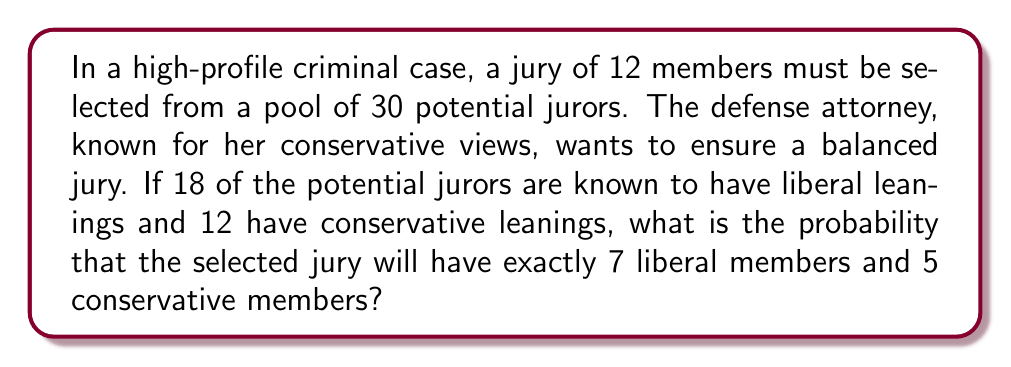Can you solve this math problem? Let's approach this step-by-step using combinatorics:

1) We need to select 7 liberal jurors out of 18 and 5 conservative jurors out of 12.

2) The number of ways to select 7 liberal jurors out of 18 is given by the combination formula:
   $$\binom{18}{7} = \frac{18!}{7!(18-7)!} = \frac{18!}{7!11!}$$

3) Similarly, the number of ways to select 5 conservative jurors out of 12 is:
   $$\binom{12}{5} = \frac{12!}{5!(12-5)!} = \frac{12!}{5!7!}$$

4) The total number of ways to select these specific combinations is the product of these two:
   $$\binom{18}{7} \cdot \binom{12}{5}$$

5) The total number of ways to select any 12 jurors out of 30 is:
   $$\binom{30}{12} = \frac{30!}{12!(30-12)!} = \frac{30!}{12!18!}$$

6) The probability is then the number of favorable outcomes divided by the total number of possible outcomes:

   $$P(\text{7 liberal, 5 conservative}) = \frac{\binom{18}{7} \cdot \binom{12}{5}}{\binom{30}{12}}$$

7) Calculating this:
   $$P = \frac{(18! / (7!11!)) \cdot (12! / (5!7!))}{30! / (12!18!)} \approx 0.1915$$
Answer: $0.1915$ or $19.15\%$ 